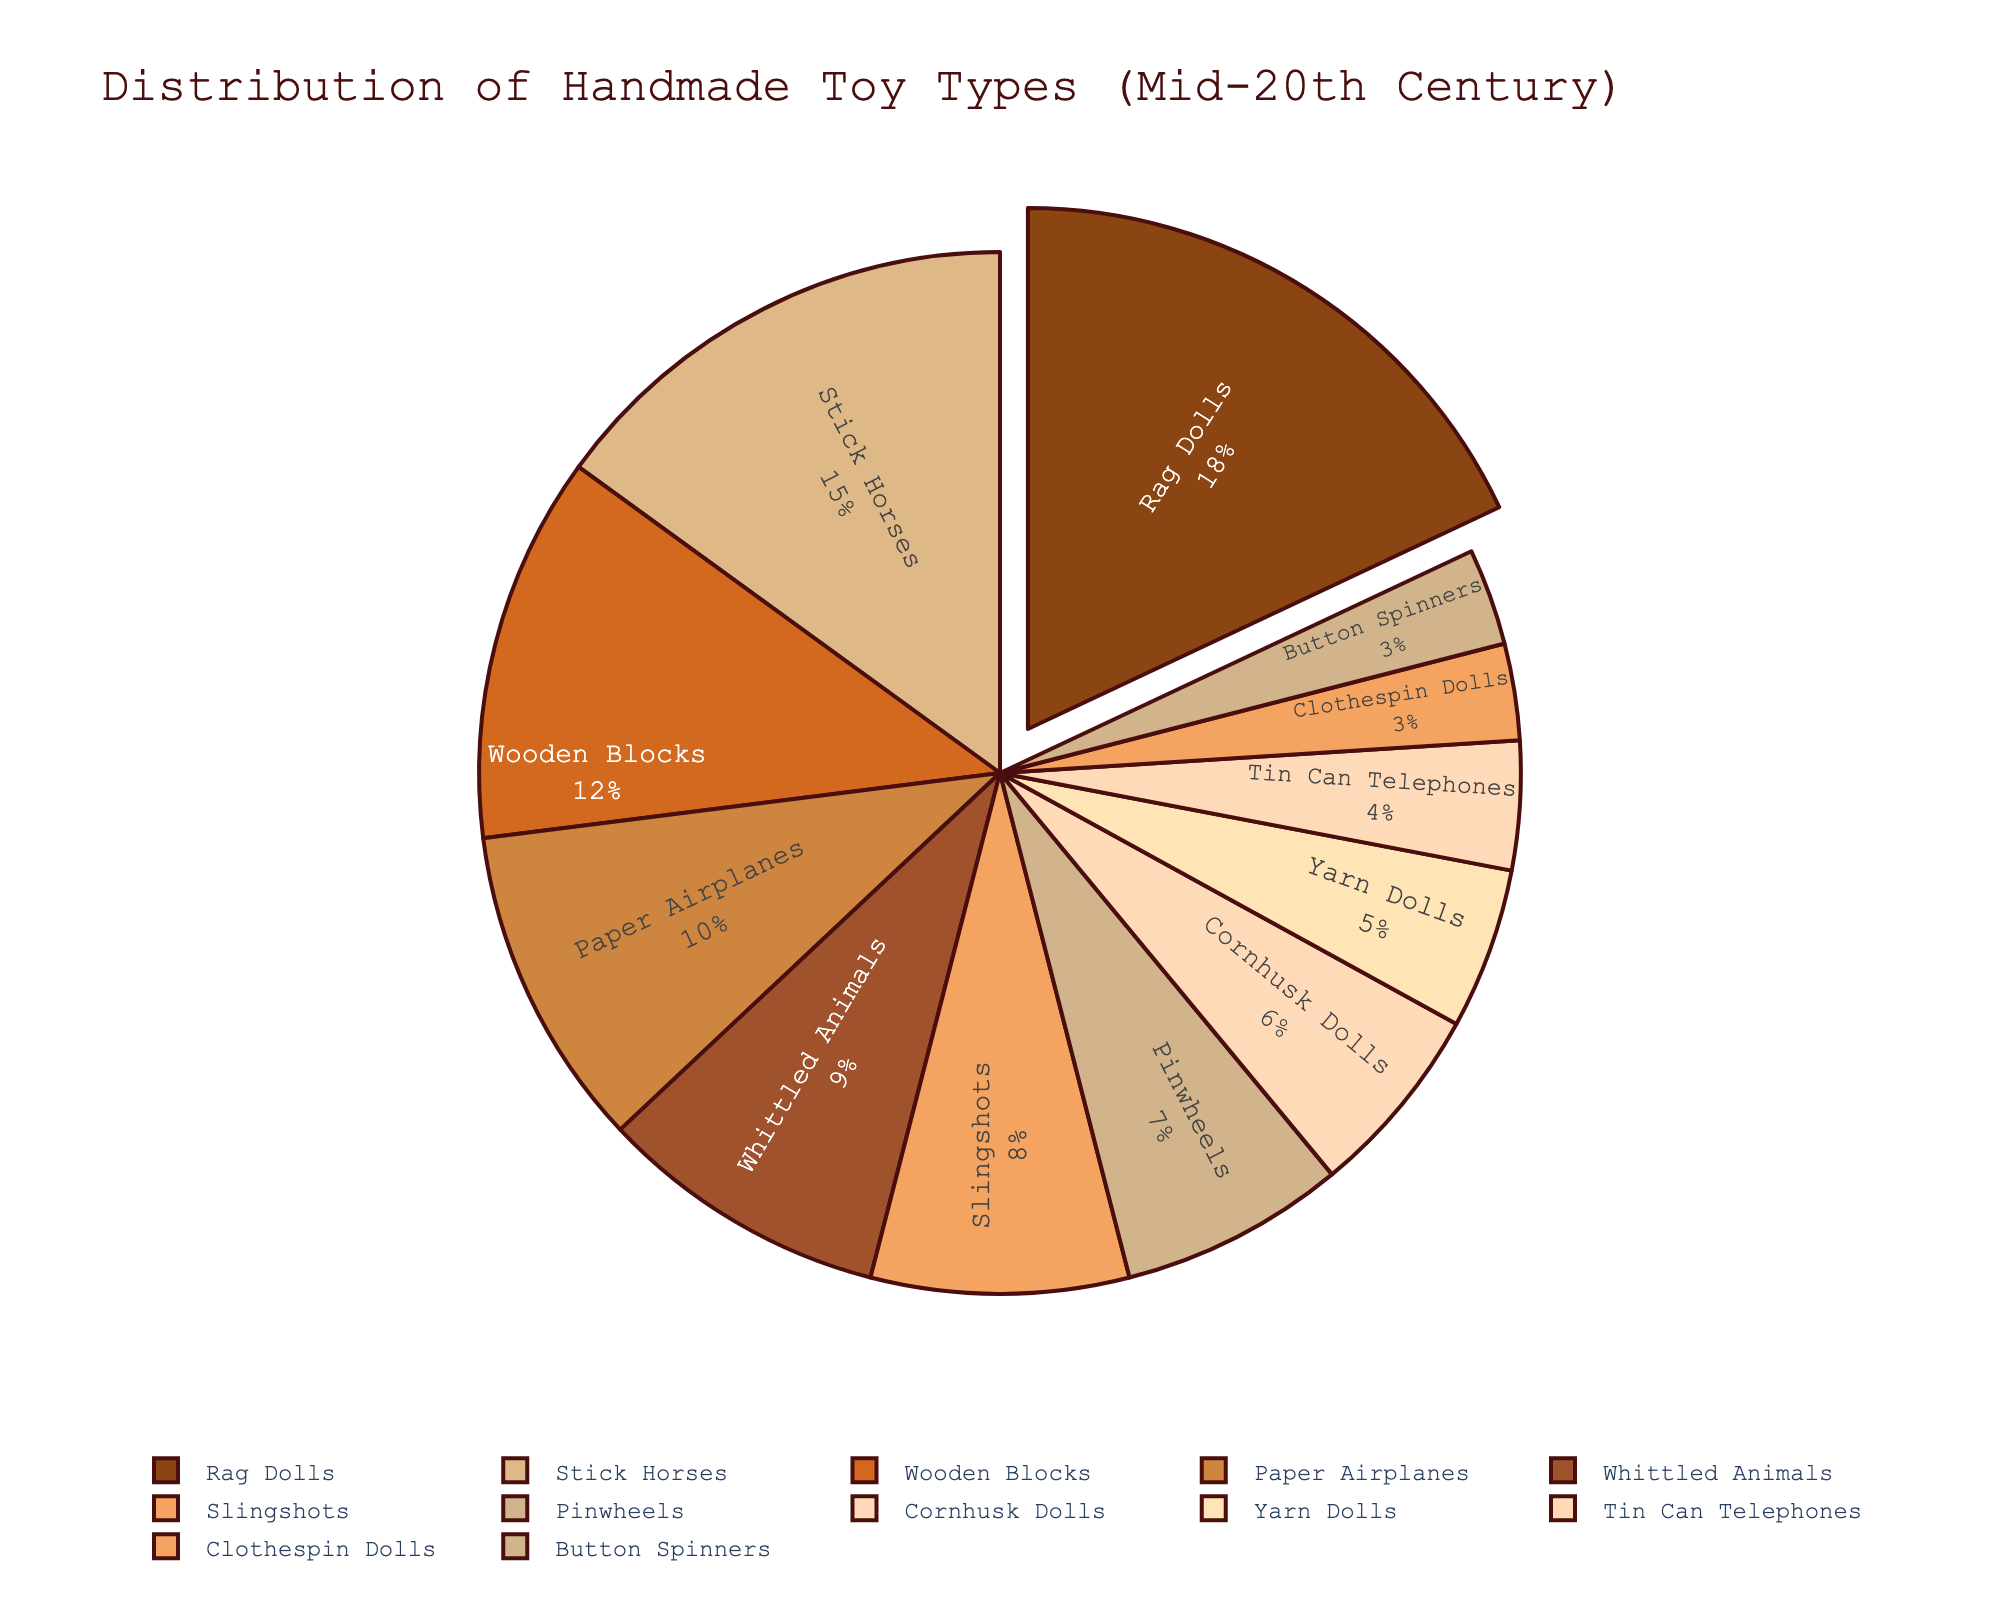What is the most common type of handmade toy crafted by children in the mid-20th century? The slice of the pie chart that is pulled out represents the most common type. This slice is for Rag Dolls, which has the highest percentage.
Answer: Rag Dolls Which two toy types have percentages adding up to the same as Stick Horses? Stick Horses have 15%. Summing the percentages of Whittled Animals (9%) and Yarn Dolls (5%) gives 14%, and adding Tin Can Telephones (4%) and Clothespin Dolls (3%) results in 7%, but Rag Dolls (18%) minus Cornhusk Dolls (6%) subtracts to 12%, thus, Wooden Blocks (12%) and Clothespin Dolls (3%) sum up 15%.
Answer: Wooden Blocks and Clothespin Dolls Which toy type is represented with the smallest slice in the pie chart? The smallest slice corresponds to the smallest percentage, which is 3%. Both Button Spinners and Clothespin Dolls have this percentage.
Answer: Button Spinners or Clothespin Dolls How much greater is the percentage of Rag Dolls compared to Paper Airplanes? Rag Dolls have 18% while Paper Airplanes have 10%. Subtracting these gives 8%.
Answer: 8% What is the combined percentage of the two least common toy types? Button Spinners and Clothespin Dolls each have a percentage of 3%. Adding these together results in a total of 6%.
Answer: 6% Which toy type categories together cover less than 10%? The categories with less than 10% are Slingshots (8%), Pinwheels (7%), Cornhusk Dolls (6%), Yarn Dolls (5%), Tin Can Telephones (4%), Clothespin Dolls (3%), and Button Spinners (3%). Only Clothespin Dolls and Button Spinners, each at 3%, sum to 6%.
Answer: Clothespin Dolls and Button Spinners Name the toys occupying at least 15% of the pie chart. The pie chart shows that Rag Dolls have 18% and Stick Horses have 15%, and no other toy type has these percentages or higher.
Answer: Rag Dolls and Stick Horses Which toy type percentage is closest to the percentage of Wooden Blocks? Wooden Blocks are at 12%, and Whittled Animals are at 9%, but Slingshots, at 8%, and Paper Airplanes, at 10%, are closest percentage-wise to Wooden Blocks. Paper Airplanes with 10% is the nearest.
Answer: Paper Airplanes Compare the total percentage of toys made from natural materials (Stick Horses, Rag Dolls, Wooden Blocks) to those made from reused materials (Button Spinners, Tin Can Telephones). The natural materials categories are Stick Horses (15%), Rag Dolls (18%), and Wooden Blocks (12%), summing to 45%. For reused materials, Button Spinners and Tin Can Telephones sum to 3% + 4% = 7%.
Answer: 45% vs. 7% 